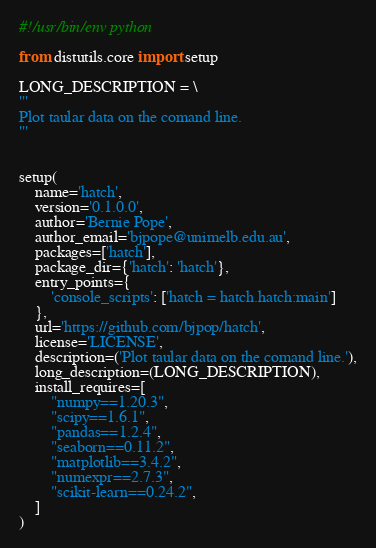<code> <loc_0><loc_0><loc_500><loc_500><_Python_>#!/usr/bin/env python

from distutils.core import setup

LONG_DESCRIPTION = \
'''
Plot taular data on the comand line.
'''


setup(
    name='hatch',
    version='0.1.0.0',
    author='Bernie Pope',
    author_email='bjpope@unimelb.edu.au',
    packages=['hatch'],
    package_dir={'hatch': 'hatch'},
    entry_points={
        'console_scripts': ['hatch = hatch.hatch:main']
    },
    url='https://github.com/bjpop/hatch',
    license='LICENSE',
    description=('Plot taular data on the comand line.'),
    long_description=(LONG_DESCRIPTION),
    install_requires=[
        "numpy==1.20.3",
        "scipy==1.6.1",
        "pandas==1.2.4",
        "seaborn==0.11.2",
        "matplotlib==3.4.2",
        "numexpr==2.7.3",
        "scikit-learn==0.24.2",
    ]
)
</code> 